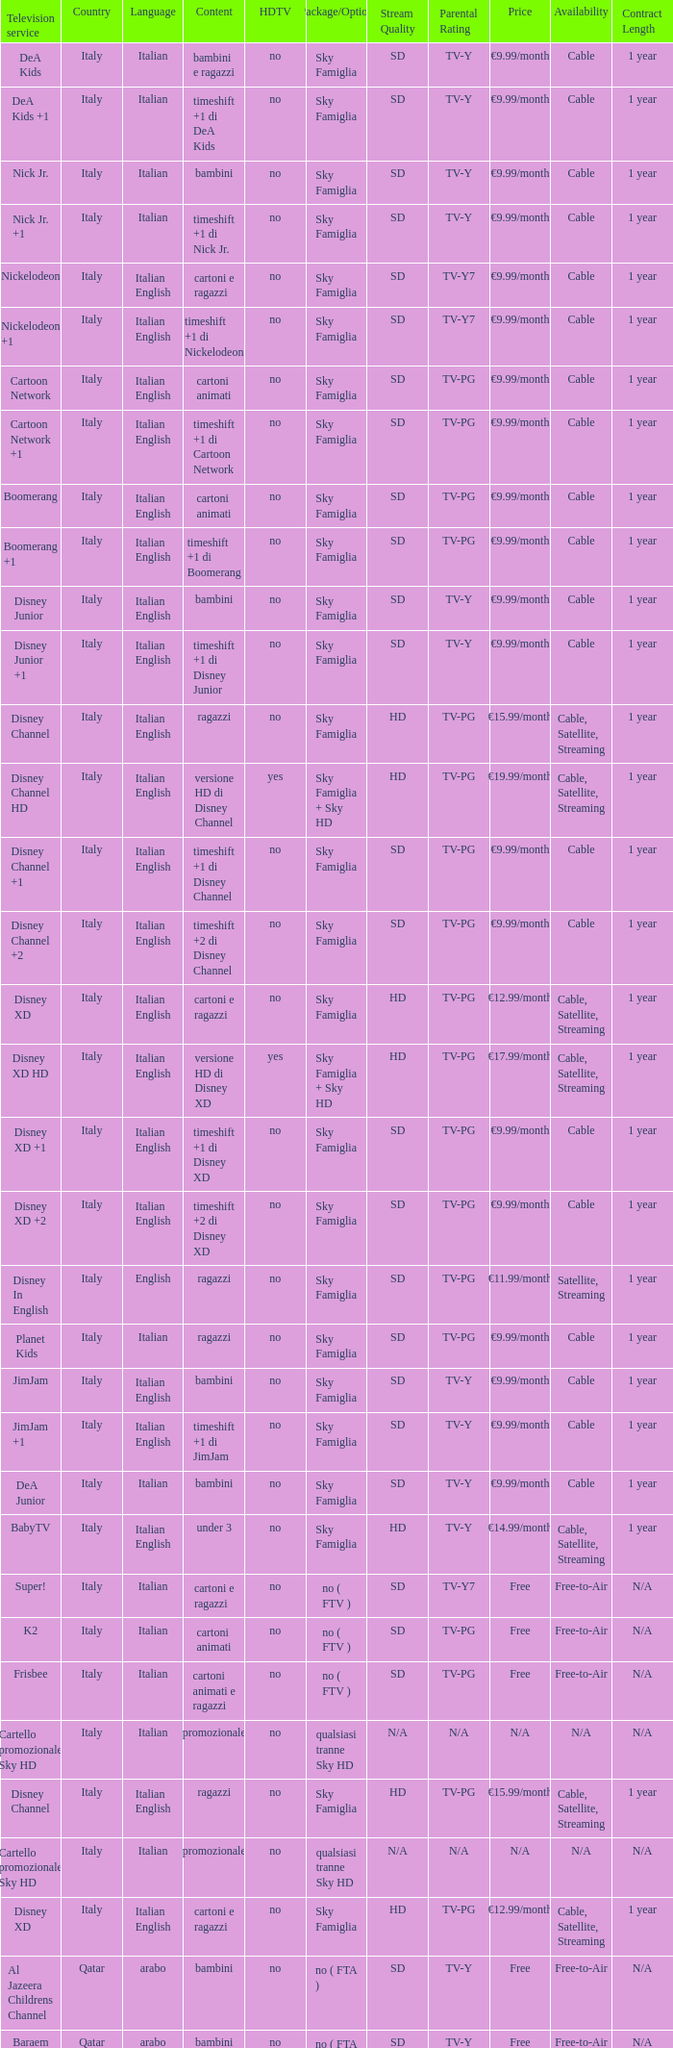What shows as Content for the Television service of nickelodeon +1? Timeshift +1 di nickelodeon. 